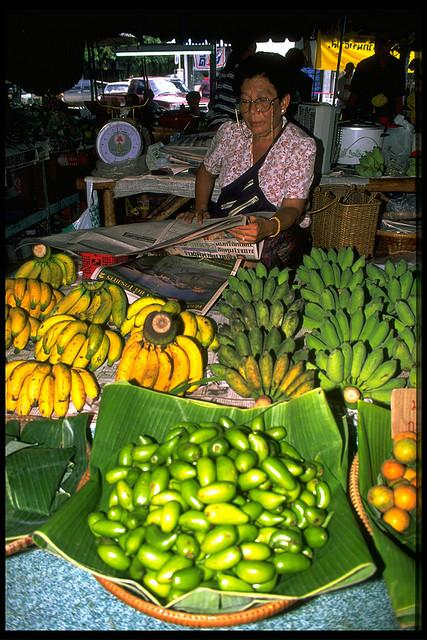What purpose does the weight in the back serve?

Choices:
A) paper weight
B) weigh money
C) balance table
D) measure price measure price 